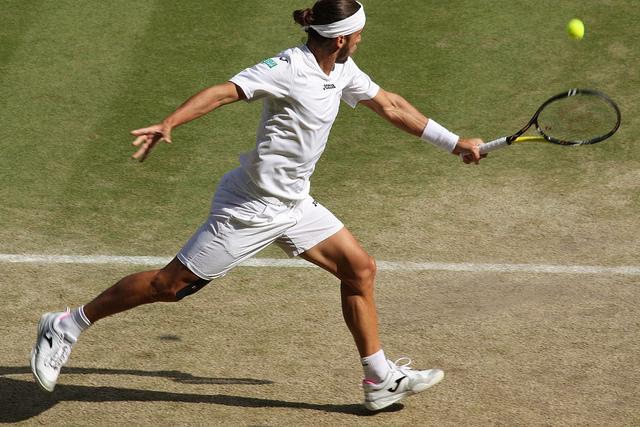Where is the person playing?
Write a very short answer. Tennis court. What sport is this?
Concise answer only. Tennis. What color is the person wearing?
Write a very short answer. White. What color is the ball?
Be succinct. Yellow. 